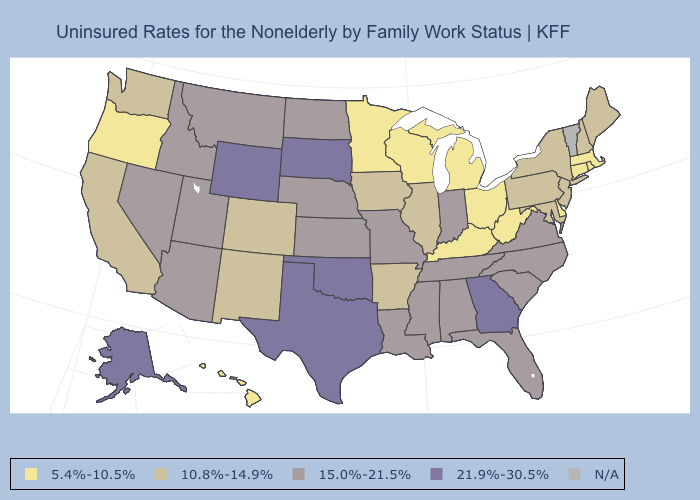What is the value of Ohio?
Be succinct. 5.4%-10.5%. Which states have the lowest value in the USA?
Concise answer only. Connecticut, Delaware, Hawaii, Kentucky, Massachusetts, Michigan, Minnesota, Ohio, Oregon, Rhode Island, West Virginia, Wisconsin. Name the states that have a value in the range 10.8%-14.9%?
Concise answer only. Arkansas, California, Colorado, Illinois, Iowa, Maine, Maryland, New Hampshire, New Jersey, New Mexico, New York, Pennsylvania, Washington. Does the first symbol in the legend represent the smallest category?
Write a very short answer. Yes. Among the states that border Texas , which have the highest value?
Give a very brief answer. Oklahoma. Among the states that border Colorado , which have the lowest value?
Give a very brief answer. New Mexico. Name the states that have a value in the range 10.8%-14.9%?
Short answer required. Arkansas, California, Colorado, Illinois, Iowa, Maine, Maryland, New Hampshire, New Jersey, New Mexico, New York, Pennsylvania, Washington. What is the lowest value in the West?
Write a very short answer. 5.4%-10.5%. What is the lowest value in states that border Iowa?
Short answer required. 5.4%-10.5%. Does Ohio have the lowest value in the MidWest?
Concise answer only. Yes. Does Alaska have the lowest value in the USA?
Quick response, please. No. Is the legend a continuous bar?
Concise answer only. No. Among the states that border Iowa , does Illinois have the highest value?
Quick response, please. No. 